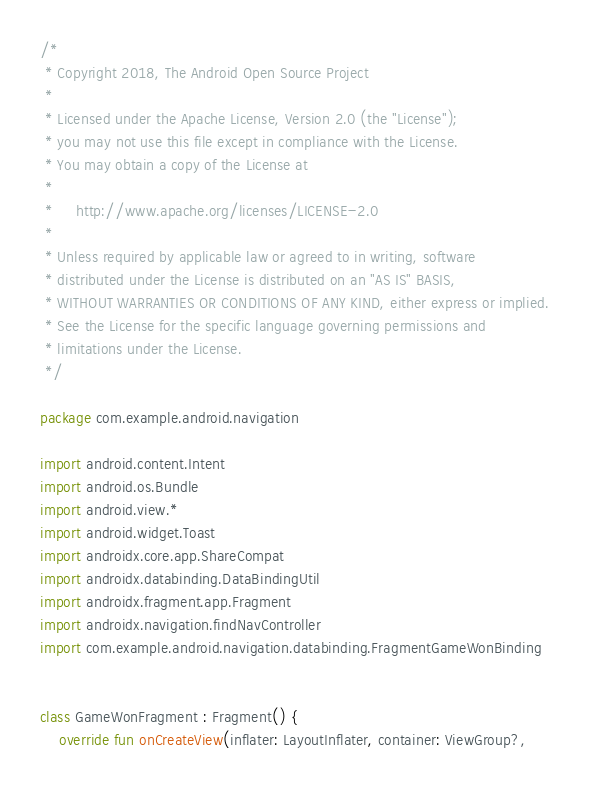<code> <loc_0><loc_0><loc_500><loc_500><_Kotlin_>/*
 * Copyright 2018, The Android Open Source Project
 *
 * Licensed under the Apache License, Version 2.0 (the "License");
 * you may not use this file except in compliance with the License.
 * You may obtain a copy of the License at
 *
 *     http://www.apache.org/licenses/LICENSE-2.0
 *
 * Unless required by applicable law or agreed to in writing, software
 * distributed under the License is distributed on an "AS IS" BASIS,
 * WITHOUT WARRANTIES OR CONDITIONS OF ANY KIND, either express or implied.
 * See the License for the specific language governing permissions and
 * limitations under the License.
 */

package com.example.android.navigation

import android.content.Intent
import android.os.Bundle
import android.view.*
import android.widget.Toast
import androidx.core.app.ShareCompat
import androidx.databinding.DataBindingUtil
import androidx.fragment.app.Fragment
import androidx.navigation.findNavController
import com.example.android.navigation.databinding.FragmentGameWonBinding


class GameWonFragment : Fragment() {
    override fun onCreateView(inflater: LayoutInflater, container: ViewGroup?,</code> 